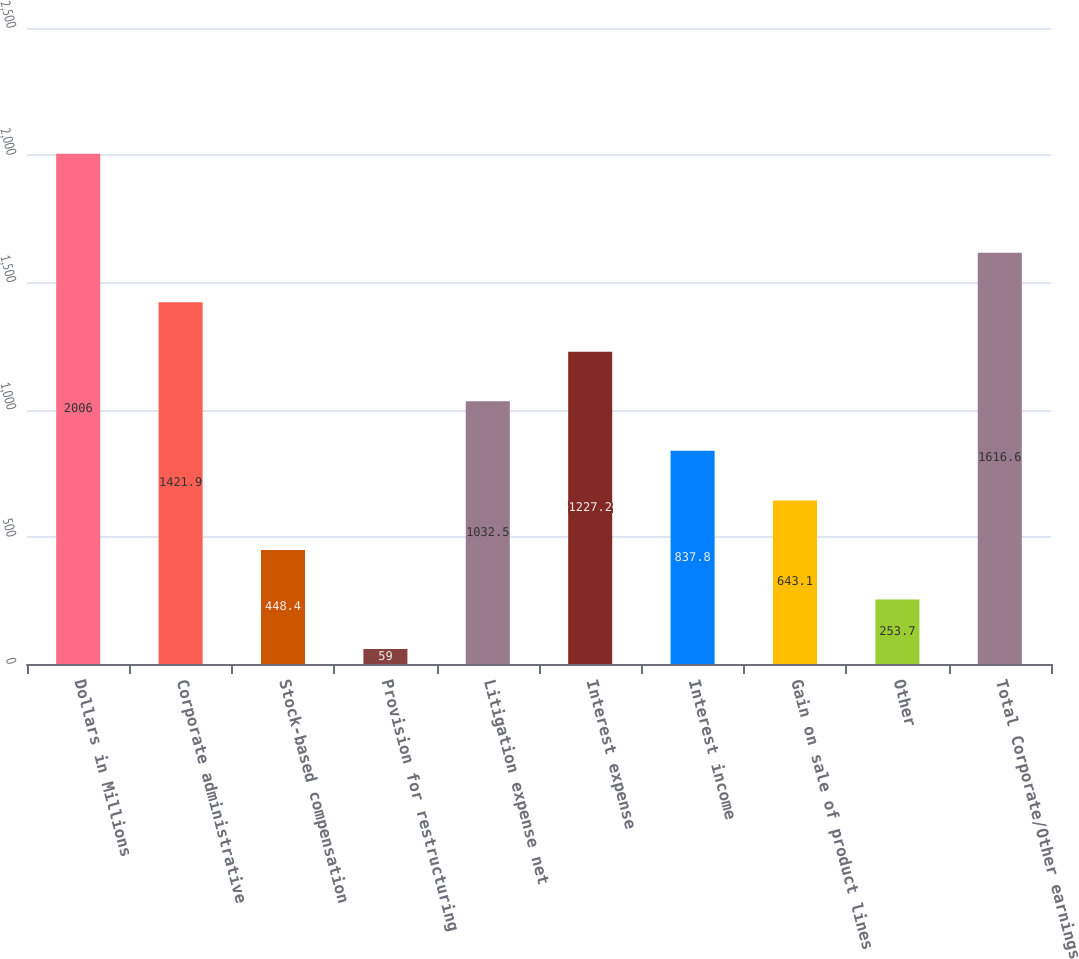Convert chart to OTSL. <chart><loc_0><loc_0><loc_500><loc_500><bar_chart><fcel>Dollars in Millions<fcel>Corporate administrative<fcel>Stock-based compensation<fcel>Provision for restructuring<fcel>Litigation expense net<fcel>Interest expense<fcel>Interest income<fcel>Gain on sale of product lines<fcel>Other<fcel>Total Corporate/Other earnings<nl><fcel>2006<fcel>1421.9<fcel>448.4<fcel>59<fcel>1032.5<fcel>1227.2<fcel>837.8<fcel>643.1<fcel>253.7<fcel>1616.6<nl></chart> 